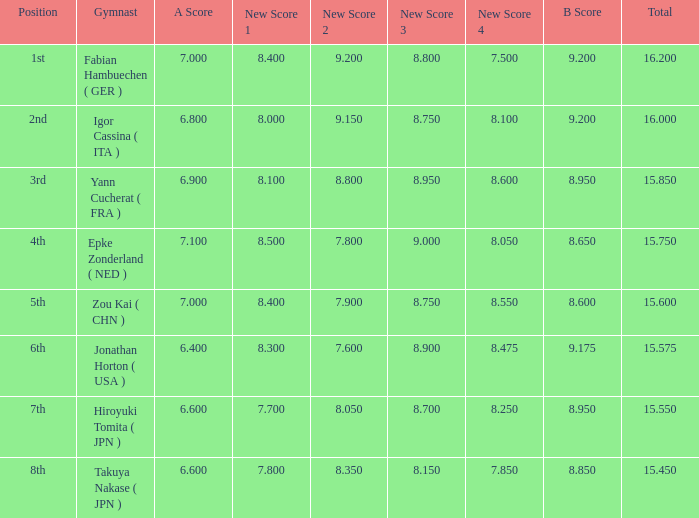What was the total rating that had a score higher than 7 and a b score smaller than 8.65? None. 